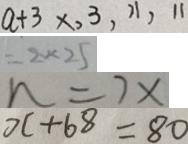Convert formula to latex. <formula><loc_0><loc_0><loc_500><loc_500>a + 3 \times , 3 , 1 1 , 1 1 
 = 2 \times 2 5 
 n = 7 x 
 x + 6 8 = 8 0</formula> 